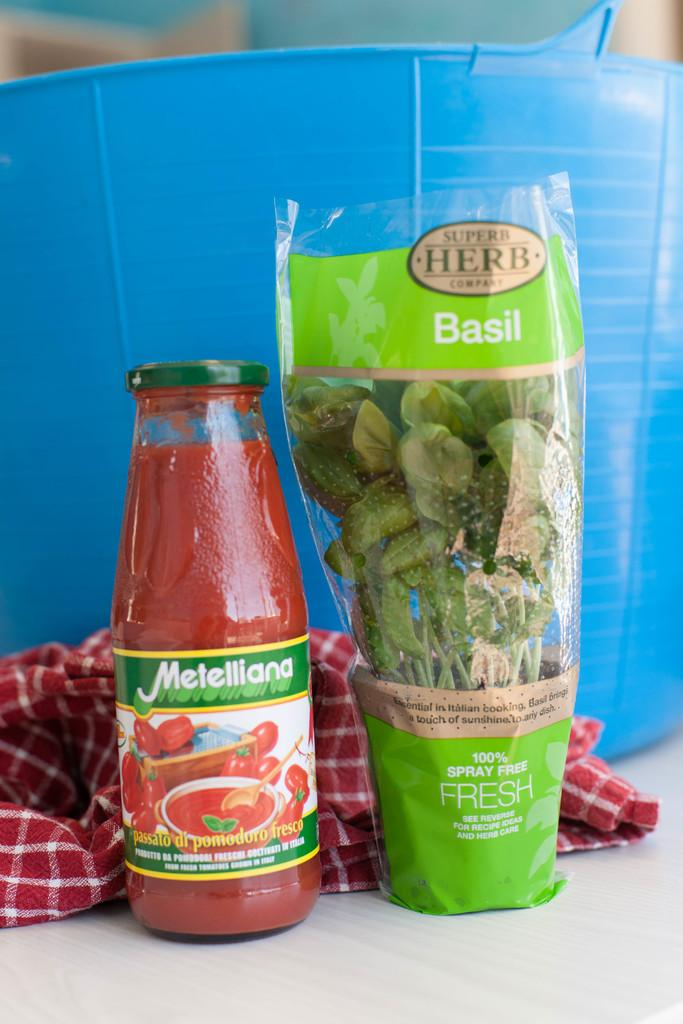What is one of the objects on the table in the image? There is a sauce bottle in the image. What else is on the table with the sauce bottle? Herbs are present in the image. Where are the sauce bottle and herbs located? The sauce bottle and herbs are on a table. What can be seen in the background of the image? There is a basket and a red cloth in the background of the image. What type of door is visible in the image? There is no door present in the image. What kind of parcel is being delivered by the apparatus in the image? There is no parcel or apparatus present in the image. 